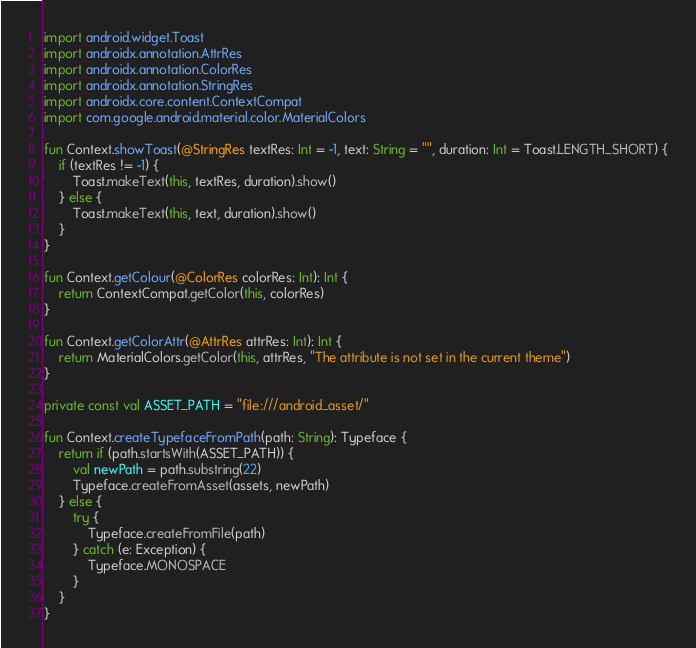Convert code to text. <code><loc_0><loc_0><loc_500><loc_500><_Kotlin_>import android.widget.Toast
import androidx.annotation.AttrRes
import androidx.annotation.ColorRes
import androidx.annotation.StringRes
import androidx.core.content.ContextCompat
import com.google.android.material.color.MaterialColors

fun Context.showToast(@StringRes textRes: Int = -1, text: String = "", duration: Int = Toast.LENGTH_SHORT) {
    if (textRes != -1) {
        Toast.makeText(this, textRes, duration).show()
    } else {
        Toast.makeText(this, text, duration).show()
    }
}

fun Context.getColour(@ColorRes colorRes: Int): Int {
    return ContextCompat.getColor(this, colorRes)
}

fun Context.getColorAttr(@AttrRes attrRes: Int): Int {
    return MaterialColors.getColor(this, attrRes, "The attribute is not set in the current theme")
}

private const val ASSET_PATH = "file:///android_asset/"

fun Context.createTypefaceFromPath(path: String): Typeface {
    return if (path.startsWith(ASSET_PATH)) {
        val newPath = path.substring(22)
        Typeface.createFromAsset(assets, newPath)
    } else {
        try {
            Typeface.createFromFile(path)
        } catch (e: Exception) {
            Typeface.MONOSPACE
        }
    }
}</code> 